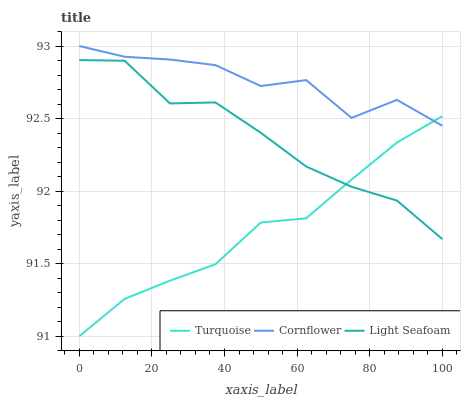Does Turquoise have the minimum area under the curve?
Answer yes or no. Yes. Does Cornflower have the maximum area under the curve?
Answer yes or no. Yes. Does Light Seafoam have the minimum area under the curve?
Answer yes or no. No. Does Light Seafoam have the maximum area under the curve?
Answer yes or no. No. Is Turquoise the smoothest?
Answer yes or no. Yes. Is Cornflower the roughest?
Answer yes or no. Yes. Is Light Seafoam the smoothest?
Answer yes or no. No. Is Light Seafoam the roughest?
Answer yes or no. No. Does Turquoise have the lowest value?
Answer yes or no. Yes. Does Light Seafoam have the lowest value?
Answer yes or no. No. Does Cornflower have the highest value?
Answer yes or no. Yes. Does Light Seafoam have the highest value?
Answer yes or no. No. Is Light Seafoam less than Cornflower?
Answer yes or no. Yes. Is Cornflower greater than Light Seafoam?
Answer yes or no. Yes. Does Turquoise intersect Cornflower?
Answer yes or no. Yes. Is Turquoise less than Cornflower?
Answer yes or no. No. Is Turquoise greater than Cornflower?
Answer yes or no. No. Does Light Seafoam intersect Cornflower?
Answer yes or no. No. 